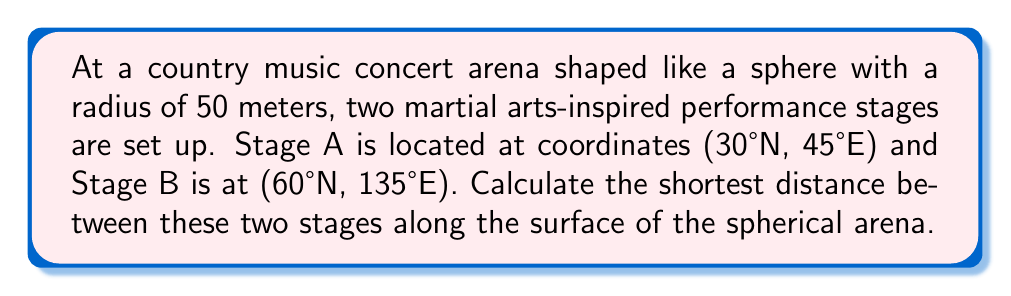Could you help me with this problem? To solve this problem, we'll use the spherical law of cosines. Here's the step-by-step solution:

1) First, we need to convert the given coordinates to radians:
   $\phi_1 = 30° \cdot \frac{\pi}{180°} = \frac{\pi}{6}$ rad
   $\lambda_1 = 45° \cdot \frac{\pi}{180°} = \frac{\pi}{4}$ rad
   $\phi_2 = 60° \cdot \frac{\pi}{180°} = \frac{\pi}{3}$ rad
   $\lambda_2 = 135° \cdot \frac{\pi}{180°} = \frac{3\pi}{4}$ rad

2) Now, we apply the spherical law of cosines:
   $$\cos(c) = \sin(\phi_1)\sin(\phi_2) + \cos(\phi_1)\cos(\phi_2)\cos(\lambda_2 - \lambda_1)$$

3) Substituting our values:
   $$\cos(c) = \sin(\frac{\pi}{6})\sin(\frac{\pi}{3}) + \cos(\frac{\pi}{6})\cos(\frac{\pi}{3})\cos(\frac{3\pi}{4} - \frac{\pi}{4})$$

4) Simplify:
   $$\cos(c) = \frac{1}{2} \cdot \frac{\sqrt{3}}{2} + \frac{\sqrt{3}}{2} \cdot \frac{1}{2} \cdot (-\frac{\sqrt{2}}{2})$$
   $$\cos(c) = \frac{\sqrt{3}}{4} - \frac{\sqrt{6}}{8} = \frac{2\sqrt{3} - \sqrt{6}}{8}$$

5) Take the arccos of both sides:
   $$c = \arccos(\frac{2\sqrt{3} - \sqrt{6}}{8})$$

6) This gives us the central angle. To get the arc length (distance), we multiply by the radius:
   $$d = 50 \cdot \arccos(\frac{2\sqrt{3} - \sqrt{6}}{8})$$

7) Calculate the final result:
   $$d \approx 50 \cdot 1.0996 = 54.98$$ meters
Answer: $54.98$ meters 